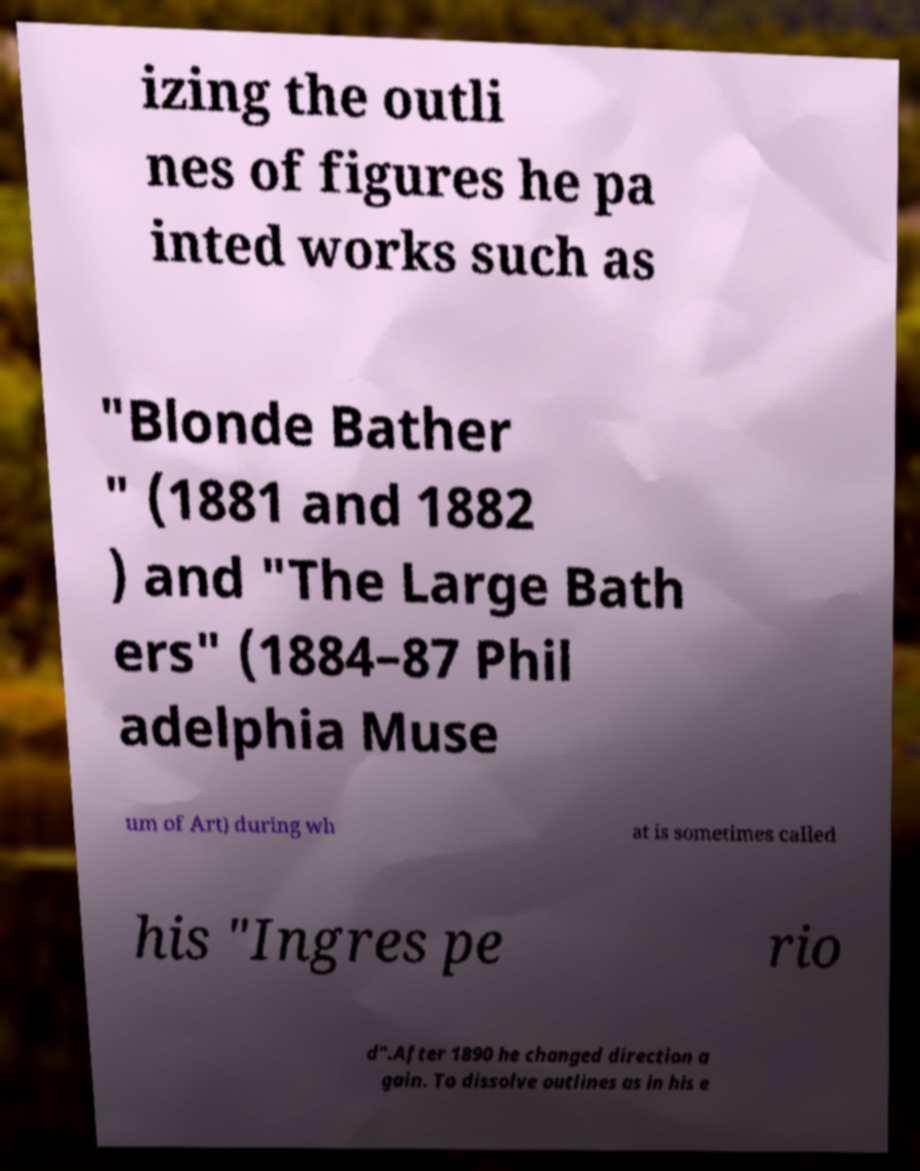Could you assist in decoding the text presented in this image and type it out clearly? izing the outli nes of figures he pa inted works such as "Blonde Bather " (1881 and 1882 ) and "The Large Bath ers" (1884–87 Phil adelphia Muse um of Art) during wh at is sometimes called his "Ingres pe rio d".After 1890 he changed direction a gain. To dissolve outlines as in his e 